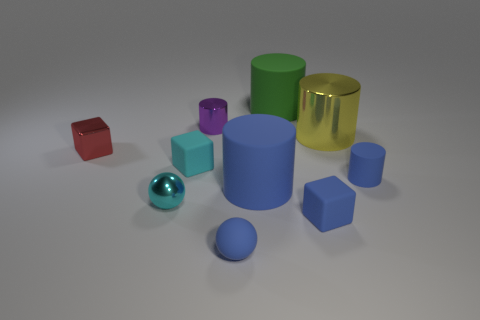What number of rubber objects have the same color as the metal ball?
Your answer should be very brief. 1. Is there any other thing that is the same color as the tiny rubber cylinder?
Give a very brief answer. Yes. Do the cyan shiny object and the yellow object have the same size?
Keep it short and to the point. No. Does the large thing that is right of the green cylinder have the same material as the green cylinder?
Provide a short and direct response. No. Are there an equal number of tiny cyan matte things in front of the cyan matte cube and tiny purple cylinders that are right of the large metal thing?
Your answer should be compact. Yes. Is there a tiny purple shiny thing that is on the left side of the tiny blue matte thing on the left side of the blue matte cube?
Make the answer very short. Yes. There is a green thing; what shape is it?
Your answer should be very brief. Cylinder. There is another matte cylinder that is the same color as the tiny matte cylinder; what size is it?
Provide a succinct answer. Large. There is a matte cube on the left side of the blue rubber cylinder left of the green cylinder; what is its size?
Provide a succinct answer. Small. How big is the ball behind the blue sphere?
Your answer should be compact. Small. 